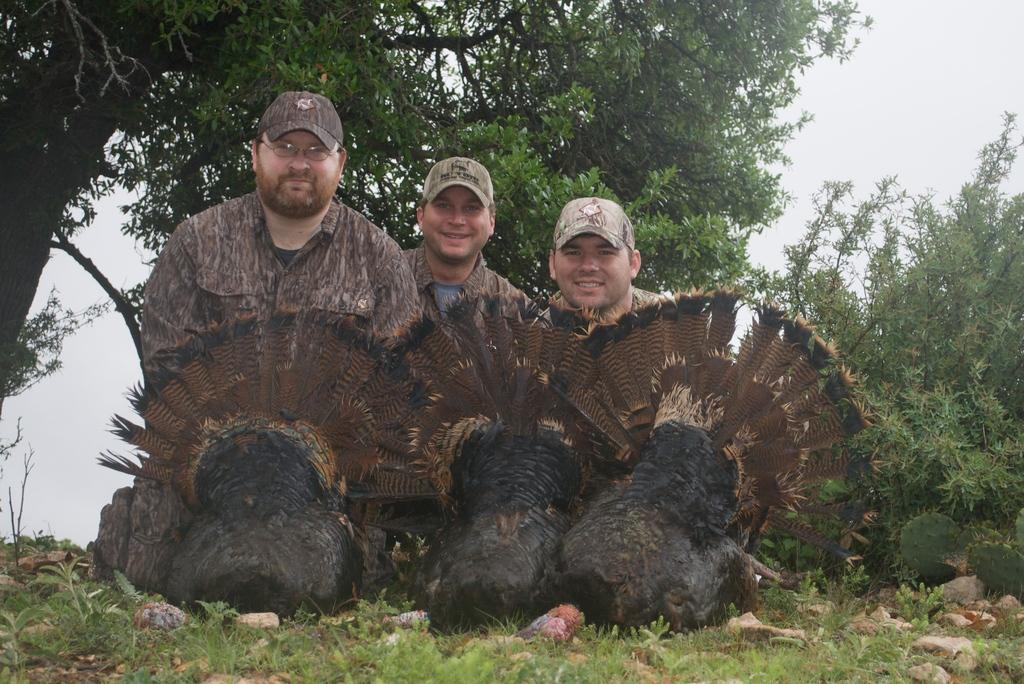How many people are in the image? There are three men in the image. What are the men doing in the image? The men are smiling in the image. What are the men wearing on their heads? The men are wearing caps in the image. What can be seen in the background of the image? There are trees and the sky visible in the background of the image. What type of berry is being steamed in the image? There is no berry or steam present in the image. 